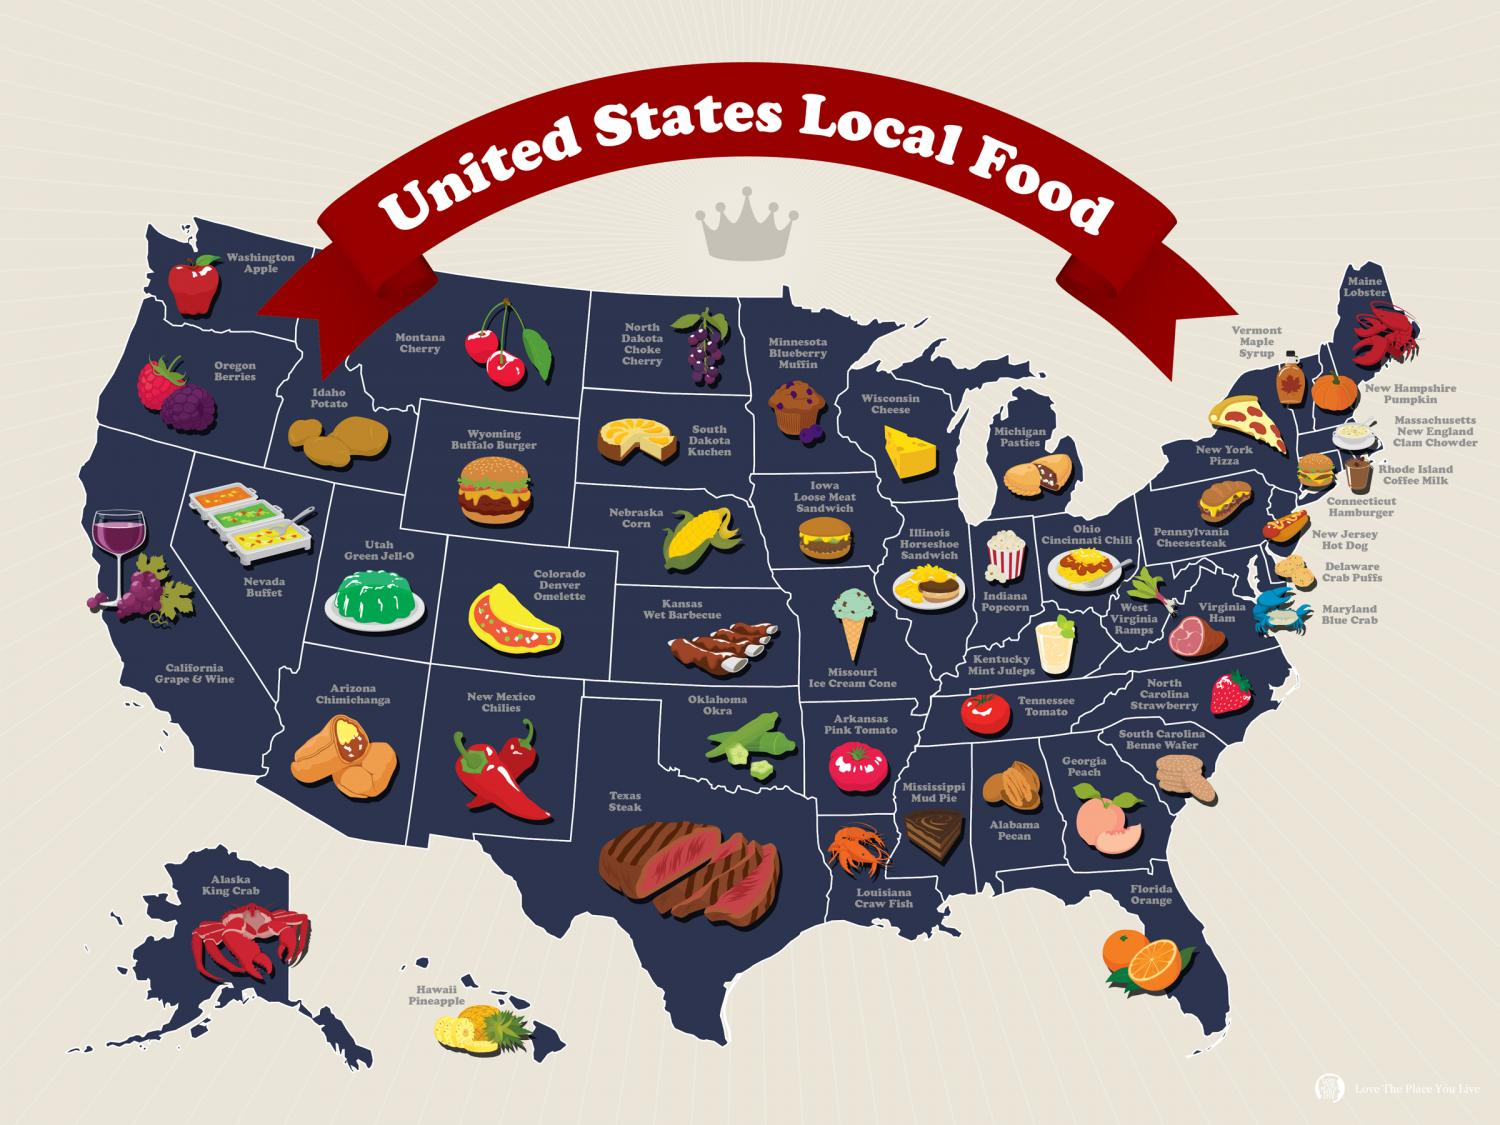Mention a couple of crucial points in this snapshot. Texas is well-known for serving some of the finest steaks in the country. The most renowned spice commonly employed in New Mexico is New Mexico Chillies. It is widely recognized that pizza is a well-known local food in New York. The locally available seafood in Alaska includes Alaska King Crab, which is a popular delicacy in the region. Georgia is renowned for its production of the delicious and succulent Georgia Peach. 